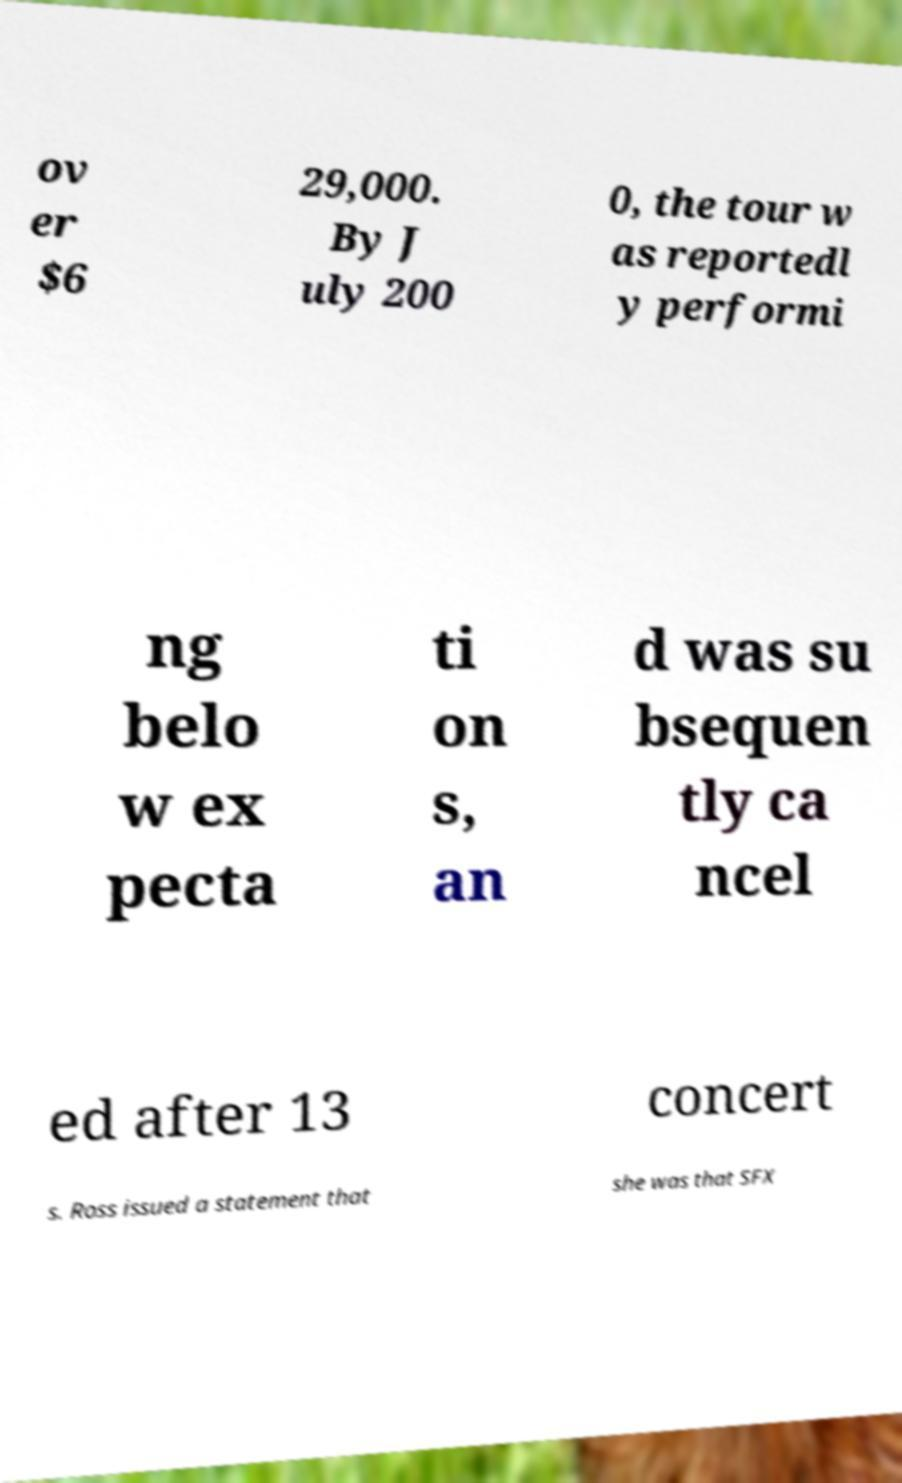Can you accurately transcribe the text from the provided image for me? ov er $6 29,000. By J uly 200 0, the tour w as reportedl y performi ng belo w ex pecta ti on s, an d was su bsequen tly ca ncel ed after 13 concert s. Ross issued a statement that she was that SFX 